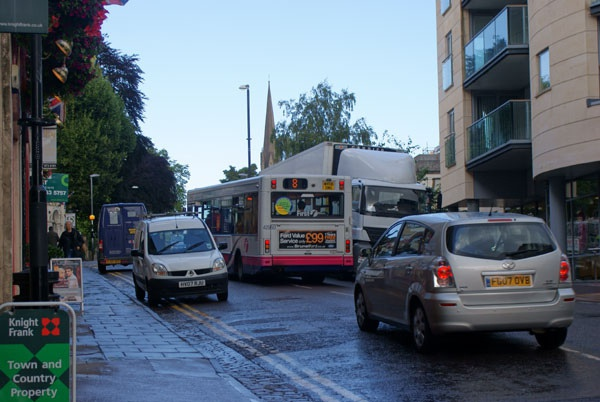Describe the objects in this image and their specific colors. I can see car in darkblue, black, gray, and darkgray tones, bus in darkblue, black, and gray tones, truck in darkblue, darkgray, black, and gray tones, truck in darkblue, black, darkgray, and gray tones, and car in darkblue, black, darkgray, and gray tones in this image. 